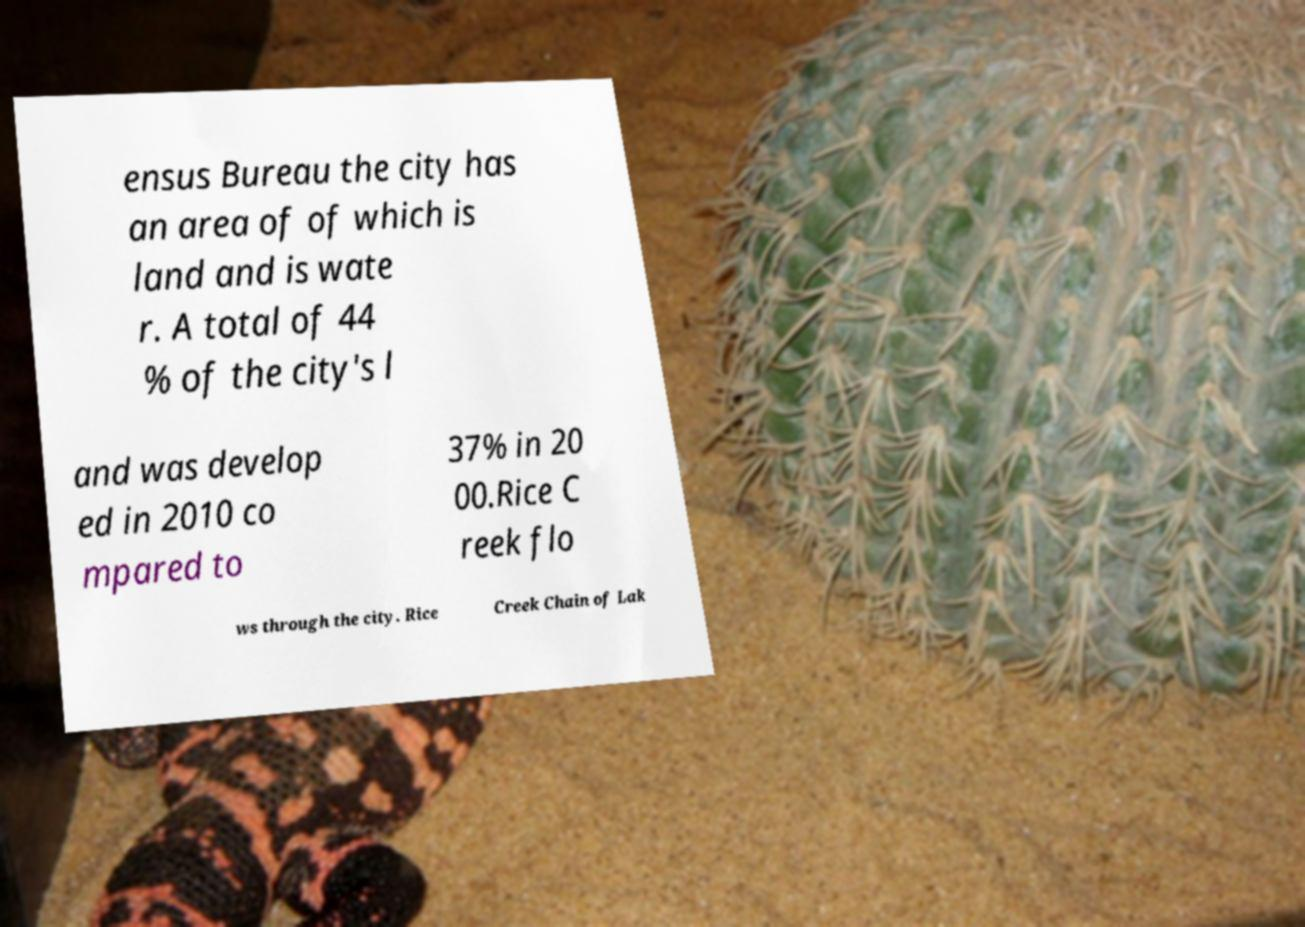Can you read and provide the text displayed in the image?This photo seems to have some interesting text. Can you extract and type it out for me? ensus Bureau the city has an area of of which is land and is wate r. A total of 44 % of the city's l and was develop ed in 2010 co mpared to 37% in 20 00.Rice C reek flo ws through the city. Rice Creek Chain of Lak 